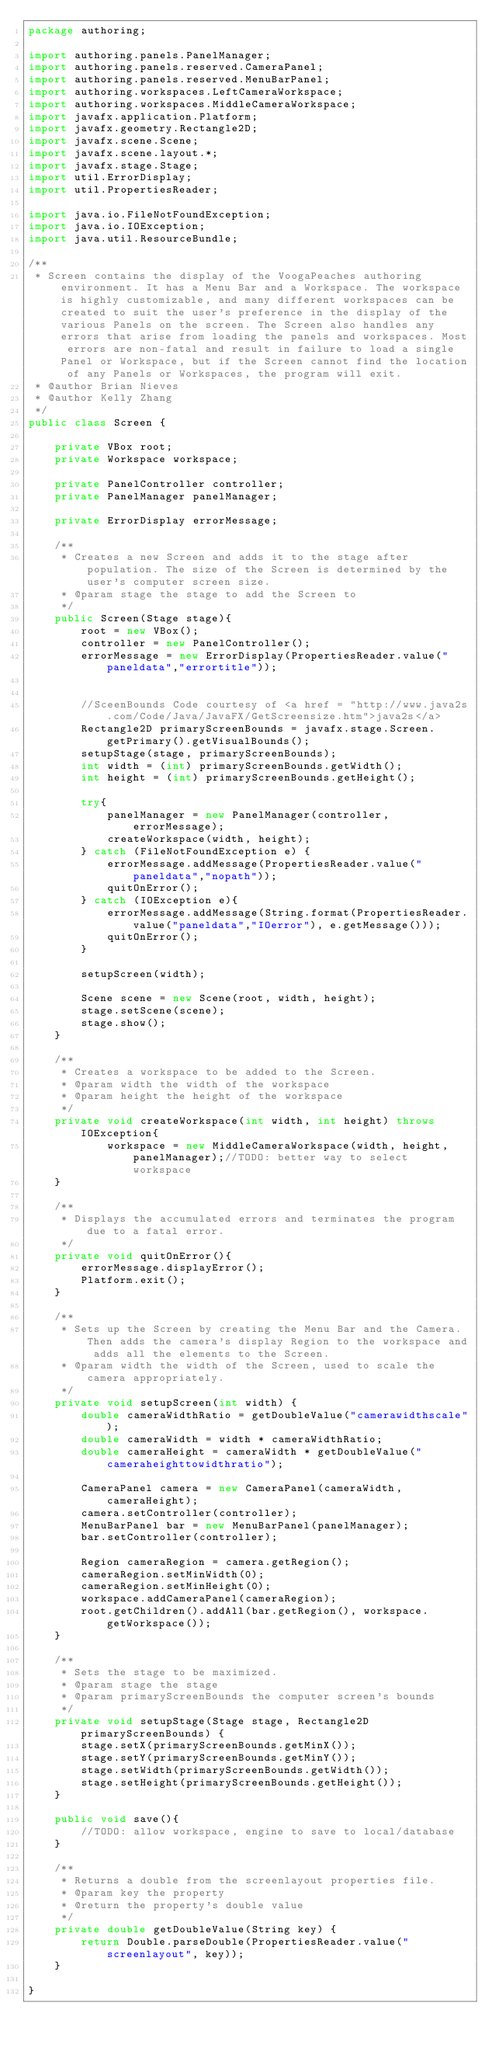Convert code to text. <code><loc_0><loc_0><loc_500><loc_500><_Java_>package authoring;

import authoring.panels.PanelManager;
import authoring.panels.reserved.CameraPanel;
import authoring.panels.reserved.MenuBarPanel;
import authoring.workspaces.LeftCameraWorkspace;
import authoring.workspaces.MiddleCameraWorkspace;
import javafx.application.Platform;
import javafx.geometry.Rectangle2D;
import javafx.scene.Scene;
import javafx.scene.layout.*;
import javafx.stage.Stage;
import util.ErrorDisplay;
import util.PropertiesReader;

import java.io.FileNotFoundException;
import java.io.IOException;
import java.util.ResourceBundle;

/**
 * Screen contains the display of the VoogaPeaches authoring environment. It has a Menu Bar and a Workspace. The workspace is highly customizable, and many different workspaces can be created to suit the user's preference in the display of the various Panels on the screen. The Screen also handles any errors that arise from loading the panels and workspaces. Most errors are non-fatal and result in failure to load a single Panel or Workspace, but if the Screen cannot find the location of any Panels or Workspaces, the program will exit.
 * @author Brian Nieves
 * @author Kelly Zhang
 */
public class Screen {

    private VBox root;
    private Workspace workspace;

    private PanelController controller;
    private PanelManager panelManager;

    private ErrorDisplay errorMessage;

    /**
     * Creates a new Screen and adds it to the stage after population. The size of the Screen is determined by the user's computer screen size.
     * @param stage the stage to add the Screen to
     */
    public Screen(Stage stage){
        root = new VBox();
        controller = new PanelController();
        errorMessage = new ErrorDisplay(PropertiesReader.value("paneldata","errortitle"));


        //SceenBounds Code courtesy of <a href = "http://www.java2s.com/Code/Java/JavaFX/GetScreensize.htm">java2s</a>
        Rectangle2D primaryScreenBounds = javafx.stage.Screen.getPrimary().getVisualBounds();
        setupStage(stage, primaryScreenBounds);
        int width = (int) primaryScreenBounds.getWidth();
        int height = (int) primaryScreenBounds.getHeight();

        try{
            panelManager = new PanelManager(controller, errorMessage);
            createWorkspace(width, height);
        } catch (FileNotFoundException e) {
            errorMessage.addMessage(PropertiesReader.value("paneldata","nopath"));
            quitOnError();
        } catch (IOException e){
            errorMessage.addMessage(String.format(PropertiesReader.value("paneldata","IOerror"), e.getMessage()));
            quitOnError();
        }

        setupScreen(width);

        Scene scene = new Scene(root, width, height);
        stage.setScene(scene);
        stage.show();
    }

    /**
     * Creates a workspace to be added to the Screen.
     * @param width the width of the workspace
     * @param height the height of the workspace
     */
    private void createWorkspace(int width, int height) throws IOException{
            workspace = new MiddleCameraWorkspace(width, height, panelManager);//TODO: better way to select workspace
    }

    /**
     * Displays the accumulated errors and terminates the program due to a fatal error.
     */
    private void quitOnError(){
        errorMessage.displayError();
        Platform.exit();
    }

    /**
     * Sets up the Screen by creating the Menu Bar and the Camera. Then adds the camera's display Region to the workspace and adds all the elements to the Screen.
     * @param width the width of the Screen, used to scale the camera appropriately.
     */
    private void setupScreen(int width) {
        double cameraWidthRatio = getDoubleValue("camerawidthscale");
        double cameraWidth = width * cameraWidthRatio;
        double cameraHeight = cameraWidth * getDoubleValue("cameraheighttowidthratio");

        CameraPanel camera = new CameraPanel(cameraWidth, cameraHeight);
        camera.setController(controller);
        MenuBarPanel bar = new MenuBarPanel(panelManager);
        bar.setController(controller);

        Region cameraRegion = camera.getRegion();
        cameraRegion.setMinWidth(0);
        cameraRegion.setMinHeight(0);
        workspace.addCameraPanel(cameraRegion);
        root.getChildren().addAll(bar.getRegion(), workspace.getWorkspace());
    }

    /**
     * Sets the stage to be maximized.
     * @param stage the stage
     * @param primaryScreenBounds the computer screen's bounds
     */
    private void setupStage(Stage stage, Rectangle2D primaryScreenBounds) {
        stage.setX(primaryScreenBounds.getMinX());
        stage.setY(primaryScreenBounds.getMinY());
        stage.setWidth(primaryScreenBounds.getWidth());
        stage.setHeight(primaryScreenBounds.getHeight());
    }

    public void save(){
        //TODO: allow workspace, engine to save to local/database
    }

    /**
     * Returns a double from the screenlayout properties file.
     * @param key the property
     * @return the property's double value
     */
    private double getDoubleValue(String key) {
        return Double.parseDouble(PropertiesReader.value("screenlayout", key));
    }

}</code> 